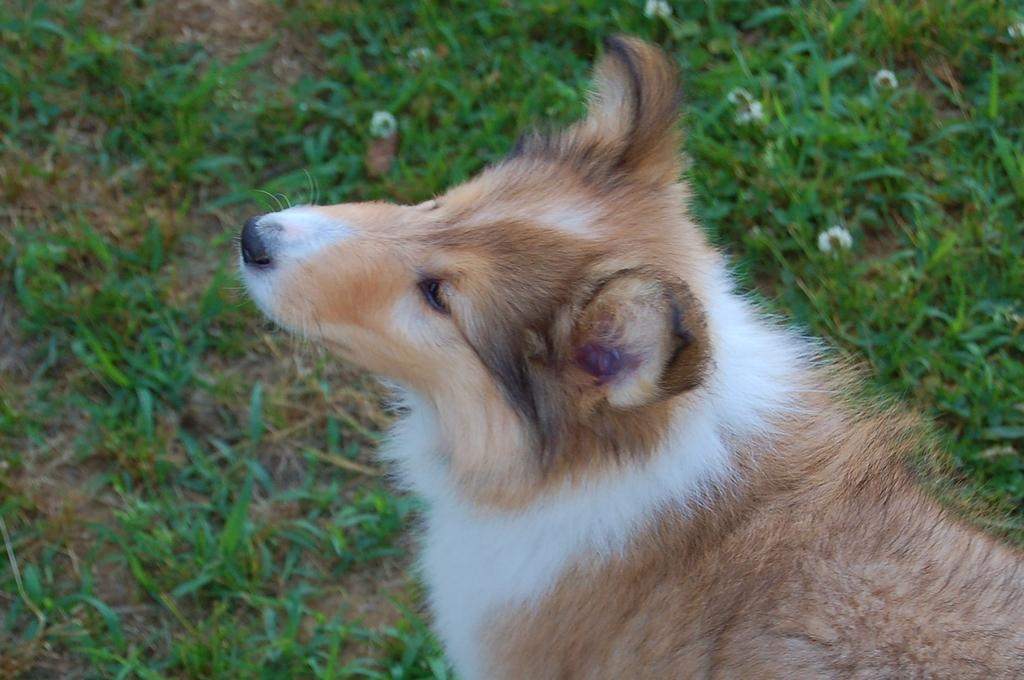What type of animal is present in the image? There is a dog in the image. What can be seen in the background of the image? There are flowers and plants on the ground in the background of the image. What type of net can be seen surrounding the dog in the image? There is no net present in the image; it only features a dog and the background elements. 